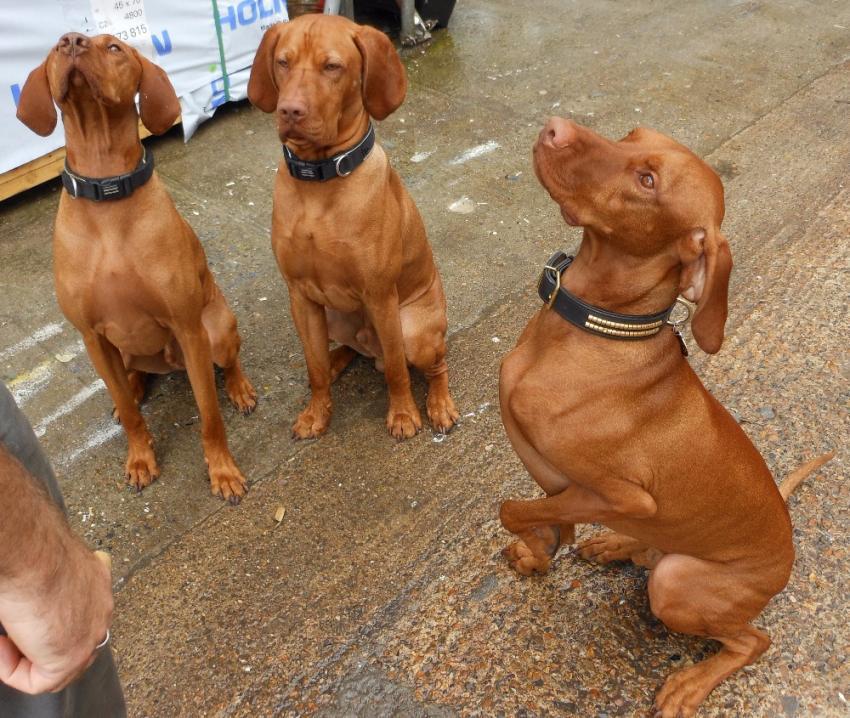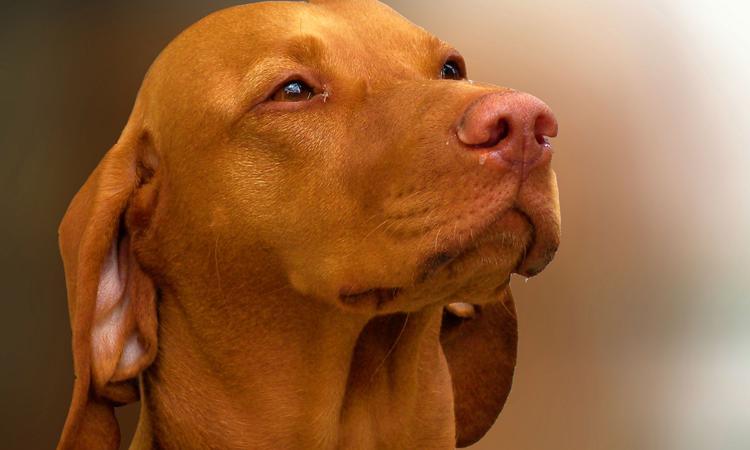The first image is the image on the left, the second image is the image on the right. Analyze the images presented: Is the assertion "At least two dogs are wearing black collars and at least half of the dogs are looking upward." valid? Answer yes or no. Yes. The first image is the image on the left, the second image is the image on the right. Examine the images to the left and right. Is the description "In at least one image you can see a single brown dog looking straight forward who is wearing a coller." accurate? Answer yes or no. No. 